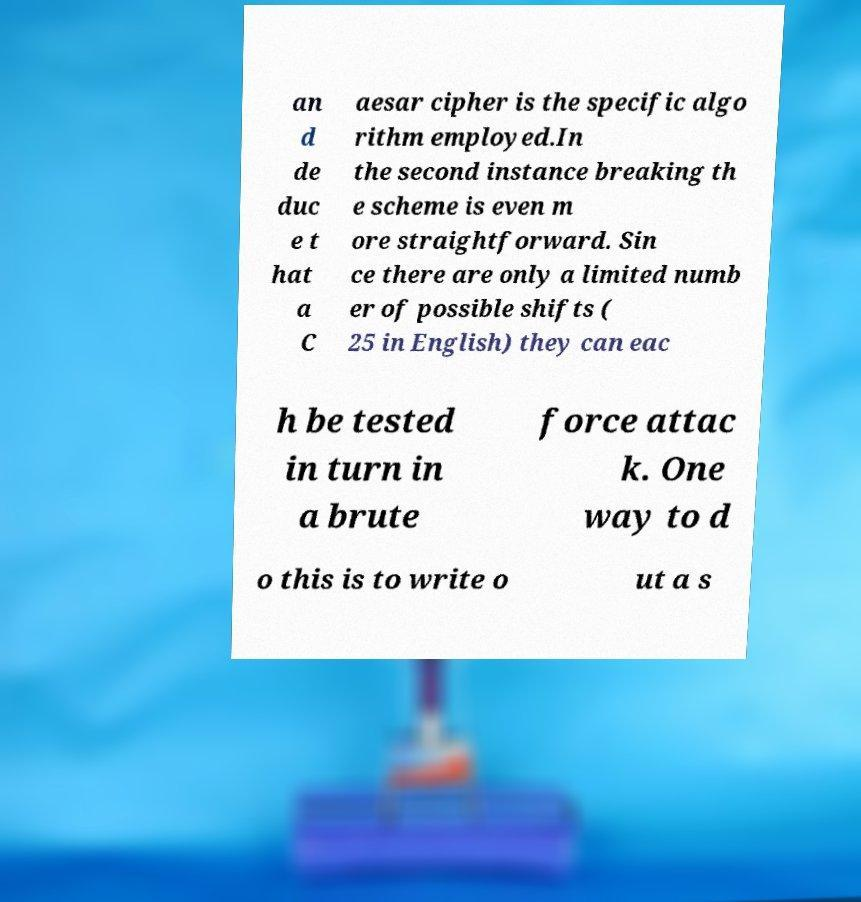Can you read and provide the text displayed in the image?This photo seems to have some interesting text. Can you extract and type it out for me? an d de duc e t hat a C aesar cipher is the specific algo rithm employed.In the second instance breaking th e scheme is even m ore straightforward. Sin ce there are only a limited numb er of possible shifts ( 25 in English) they can eac h be tested in turn in a brute force attac k. One way to d o this is to write o ut a s 